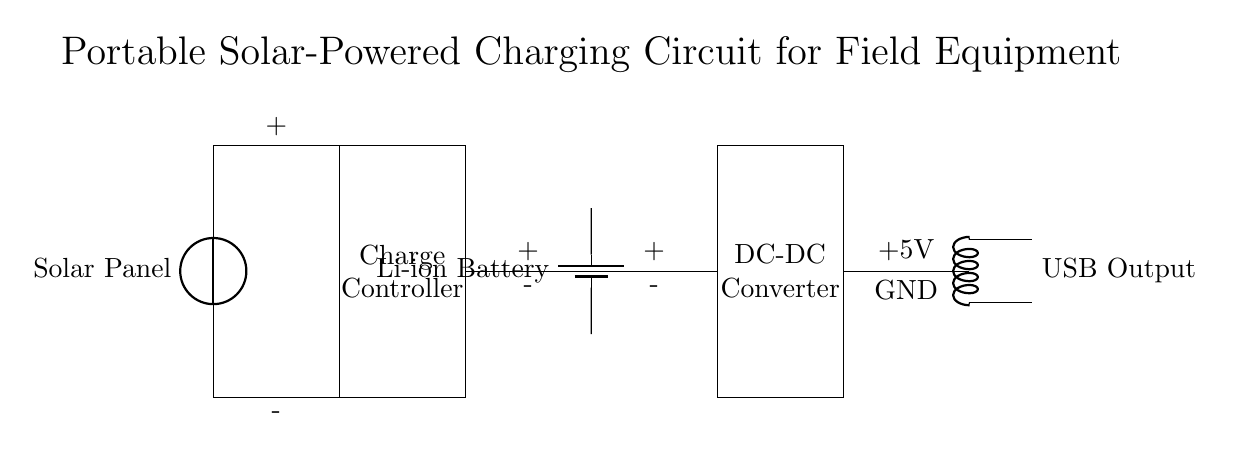What type of battery is used in this circuit? The circuit diagram labels the battery as a "Li-ion Battery," indicating the type of battery that is used in the design.
Answer: Li-ion Battery What is the function of the charge controller in this circuit? The charge controller regulates the voltage and current coming from the solar panel to ensure correct charging of the battery, which is critical to prevent overcharging and damage.
Answer: Regulates charging What voltage does the USB output provide? The circuit directly states that the USB output provides a voltage of "5V," which indicates the output voltage available for devices.
Answer: 5V How many main components are shown in this circuit? The diagram illustrates four main components: a solar panel, a charge controller, a battery, and a DC-DC converter. Counting these provides the total number of components.
Answer: Four What is the purpose of the DC-DC converter in this circuit? The DC-DC converter adjusts the voltage from the battery to the required level for the USB output, ensuring compatibility with devices that require a specific voltage.
Answer: Voltage adjustment What is the connection type between the charge controller and the battery? The diagram shows a direct connection between the charge controller and the battery, where the positive and negative terminals are connected to allow charging.
Answer: Direct connection 